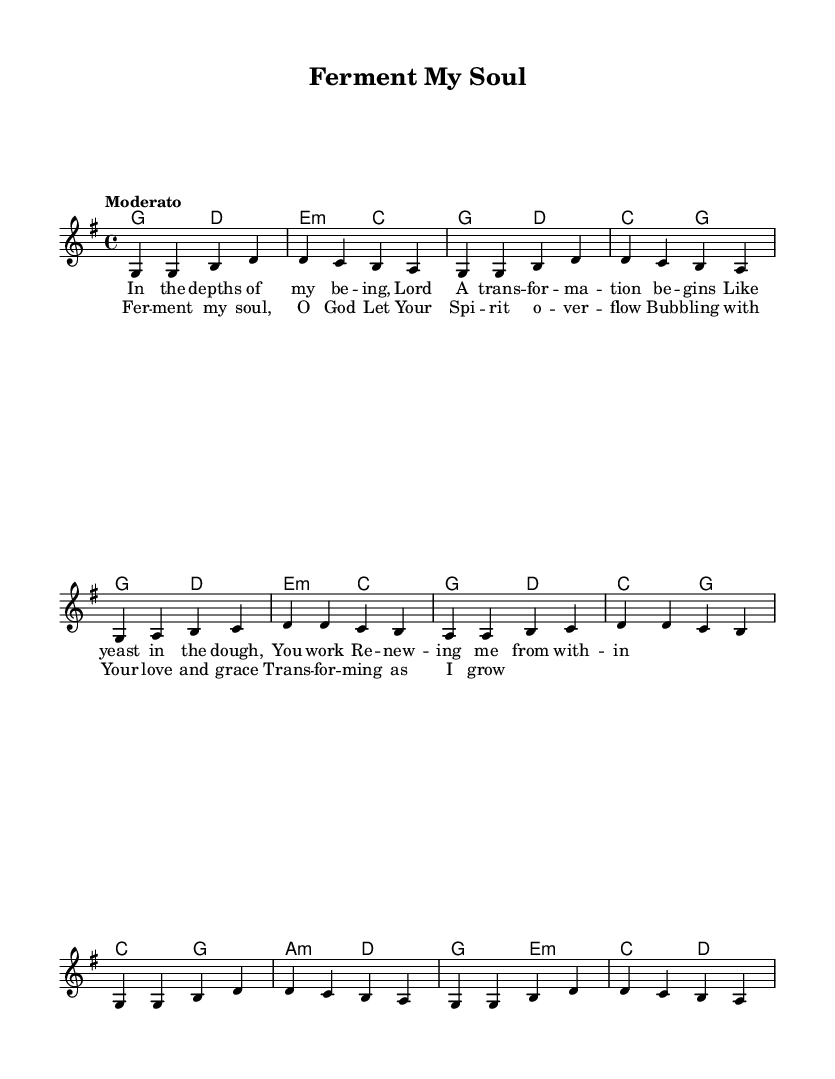What is the key signature of this music? The key signature is G major, which has one sharp (F#). This can be determined by looking at the key signature indicated at the beginning of the sheet music, just after the clef sign.
Answer: G major What is the time signature of this piece? The time signature is 4/4, indicated at the beginning of the score. This means there are four beats in a measure and the quarter note gets the beat.
Answer: 4/4 What is the tempo marking of the piece? The tempo marking is "Moderato," which suggests a moderate speed for the song. This is located near the beginning of the sheet music, where tempo is usually indicated.
Answer: Moderato How many measures are in the verse? There are eight measures in the verse, each separated by a vertical line, indicating the end of each measure. Counting them reveals there are eight distinct groups of notes.
Answer: 8 What thematic element in the lyrics represents transformation? The phrase "A trans -- for -- ma -- tion" signifies transformation in the lyrics, reflecting the change or renewal process akin to fermentation. This specific aspect is evident in the text of the first verse of the song.
Answer: Transformation Which musical section follows the verse in this piece? The section that follows the verse is the chorus, as indicated by the structure of the song where verses alternate with a repeated chorus. The chorus text clearly follows the verse text in the layout.
Answer: Chorus 